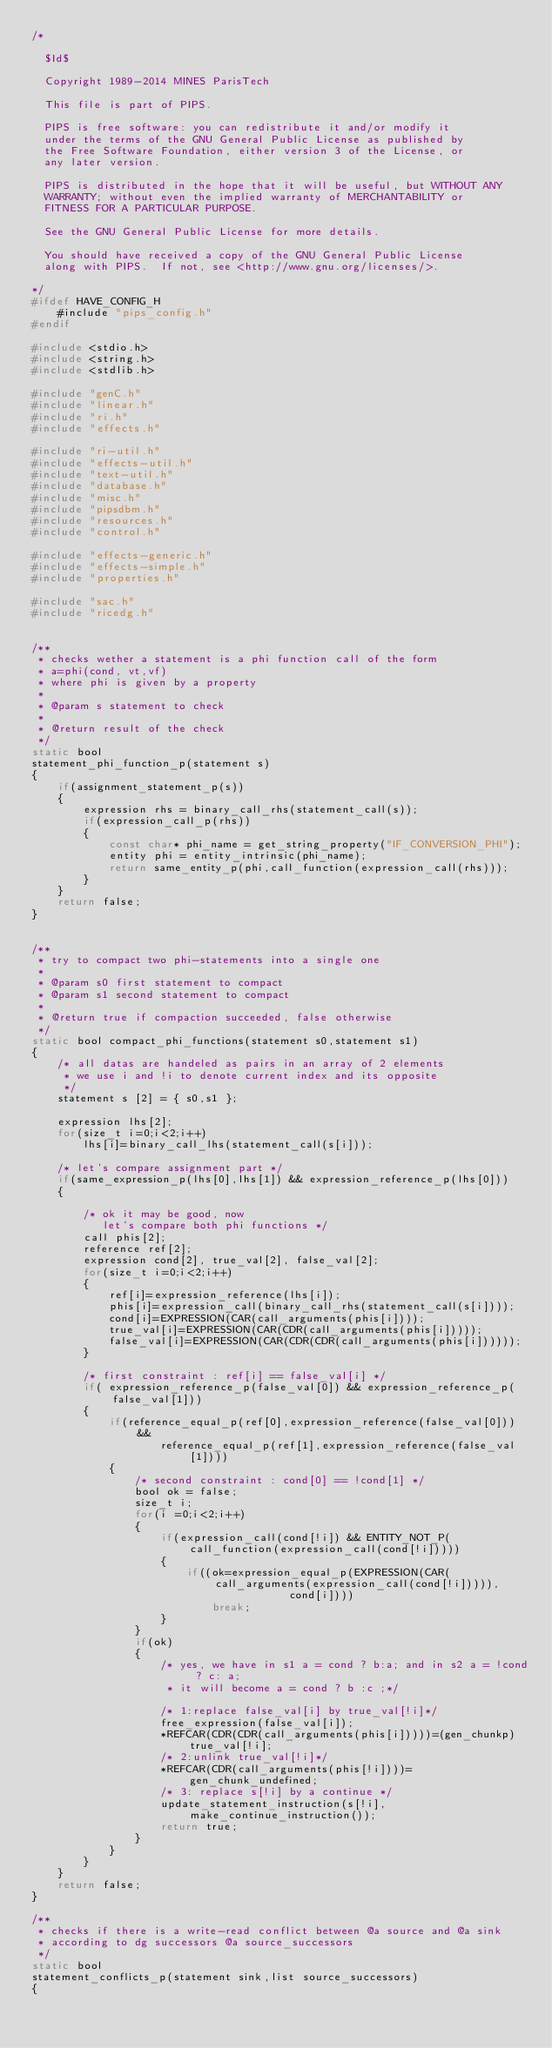Convert code to text. <code><loc_0><loc_0><loc_500><loc_500><_C_>/*

  $Id$

  Copyright 1989-2014 MINES ParisTech

  This file is part of PIPS.

  PIPS is free software: you can redistribute it and/or modify it
  under the terms of the GNU General Public License as published by
  the Free Software Foundation, either version 3 of the License, or
  any later version.

  PIPS is distributed in the hope that it will be useful, but WITHOUT ANY
  WARRANTY; without even the implied warranty of MERCHANTABILITY or
  FITNESS FOR A PARTICULAR PURPOSE.

  See the GNU General Public License for more details.

  You should have received a copy of the GNU General Public License
  along with PIPS.  If not, see <http://www.gnu.org/licenses/>.

*/
#ifdef HAVE_CONFIG_H
    #include "pips_config.h"
#endif

#include <stdio.h>
#include <string.h>
#include <stdlib.h>

#include "genC.h"
#include "linear.h"
#include "ri.h"
#include "effects.h"

#include "ri-util.h"
#include "effects-util.h"
#include "text-util.h"
#include "database.h"
#include "misc.h"
#include "pipsdbm.h"
#include "resources.h"
#include "control.h"

#include "effects-generic.h"
#include "effects-simple.h"
#include "properties.h"

#include "sac.h"
#include "ricedg.h"


/** 
 * checks wether a statement is a phi function call of the form
 * a=phi(cond, vt,vf)
 * where phi is given by a property
 * 
 * @param s statement to check
 * 
 * @return result of the check
 */
static bool
statement_phi_function_p(statement s)
{
    if(assignment_statement_p(s))
    {
        expression rhs = binary_call_rhs(statement_call(s));
        if(expression_call_p(rhs))
        {
            const char* phi_name = get_string_property("IF_CONVERSION_PHI");
            entity phi = entity_intrinsic(phi_name);
            return same_entity_p(phi,call_function(expression_call(rhs)));
        }
    }
    return false;
}


/** 
 * try to compact two phi-statements into a single one
 * 
 * @param s0 first statement to compact
 * @param s1 second statement to compact
 * 
 * @return true if compaction succeeded, false otherwise
 */
static bool compact_phi_functions(statement s0,statement s1)
{
    /* all datas are handeled as pairs in an array of 2 elements
     * we use i and !i to denote current index and its opposite
     */
    statement s [2] = { s0,s1 };

    expression lhs[2];
    for(size_t i=0;i<2;i++)
        lhs[i]=binary_call_lhs(statement_call(s[i]));

    /* let's compare assignment part */
    if(same_expression_p(lhs[0],lhs[1]) && expression_reference_p(lhs[0]))
    {

        /* ok it may be good, now
           let's compare both phi functions */
        call phis[2];
        reference ref[2];
        expression cond[2], true_val[2], false_val[2];
        for(size_t i=0;i<2;i++)
        {
            ref[i]=expression_reference(lhs[i]);
            phis[i]=expression_call(binary_call_rhs(statement_call(s[i])));
            cond[i]=EXPRESSION(CAR(call_arguments(phis[i])));
            true_val[i]=EXPRESSION(CAR(CDR(call_arguments(phis[i]))));
            false_val[i]=EXPRESSION(CAR(CDR(CDR(call_arguments(phis[i])))));
        }

        /* first constraint : ref[i] == false_val[i] */
        if( expression_reference_p(false_val[0]) && expression_reference_p(false_val[1]))
        {
            if(reference_equal_p(ref[0],expression_reference(false_val[0])) &&
                    reference_equal_p(ref[1],expression_reference(false_val[1])))
            {
                /* second constraint : cond[0] == !cond[1] */
                bool ok = false;
                size_t i;
                for(i =0;i<2;i++)
                {
                    if(expression_call(cond[!i]) && ENTITY_NOT_P(call_function(expression_call(cond[!i]))))
                    {
                        if((ok=expression_equal_p(EXPRESSION(CAR(call_arguments(expression_call(cond[!i])))),
                                        cond[i])))
                            break;
                    }
                }
                if(ok)
                {
                    /* yes, we have in s1 a = cond ? b:a; and in s2 a = !cond ? c: a;
                     * it will become a = cond ? b :c ;*/

                    /* 1:replace false_val[i] by true_val[!i]*/
                    free_expression(false_val[i]);
                    *REFCAR(CDR(CDR(call_arguments(phis[i]))))=(gen_chunkp)true_val[!i];
                    /* 2:unlink true_val[!i]*/
                    *REFCAR(CDR(call_arguments(phis[!i])))=gen_chunk_undefined;
                    /* 3: replace s[!i] by a continue */
                    update_statement_instruction(s[!i],make_continue_instruction());
                    return true;
                }
            }
        }
    }
    return false;
}

/** 
 * checks if there is a write-read conflict between @a source and @a sink
 * according to dg successors @a source_successors
 */
static bool
statement_conflicts_p(statement sink,list source_successors)
{</code> 